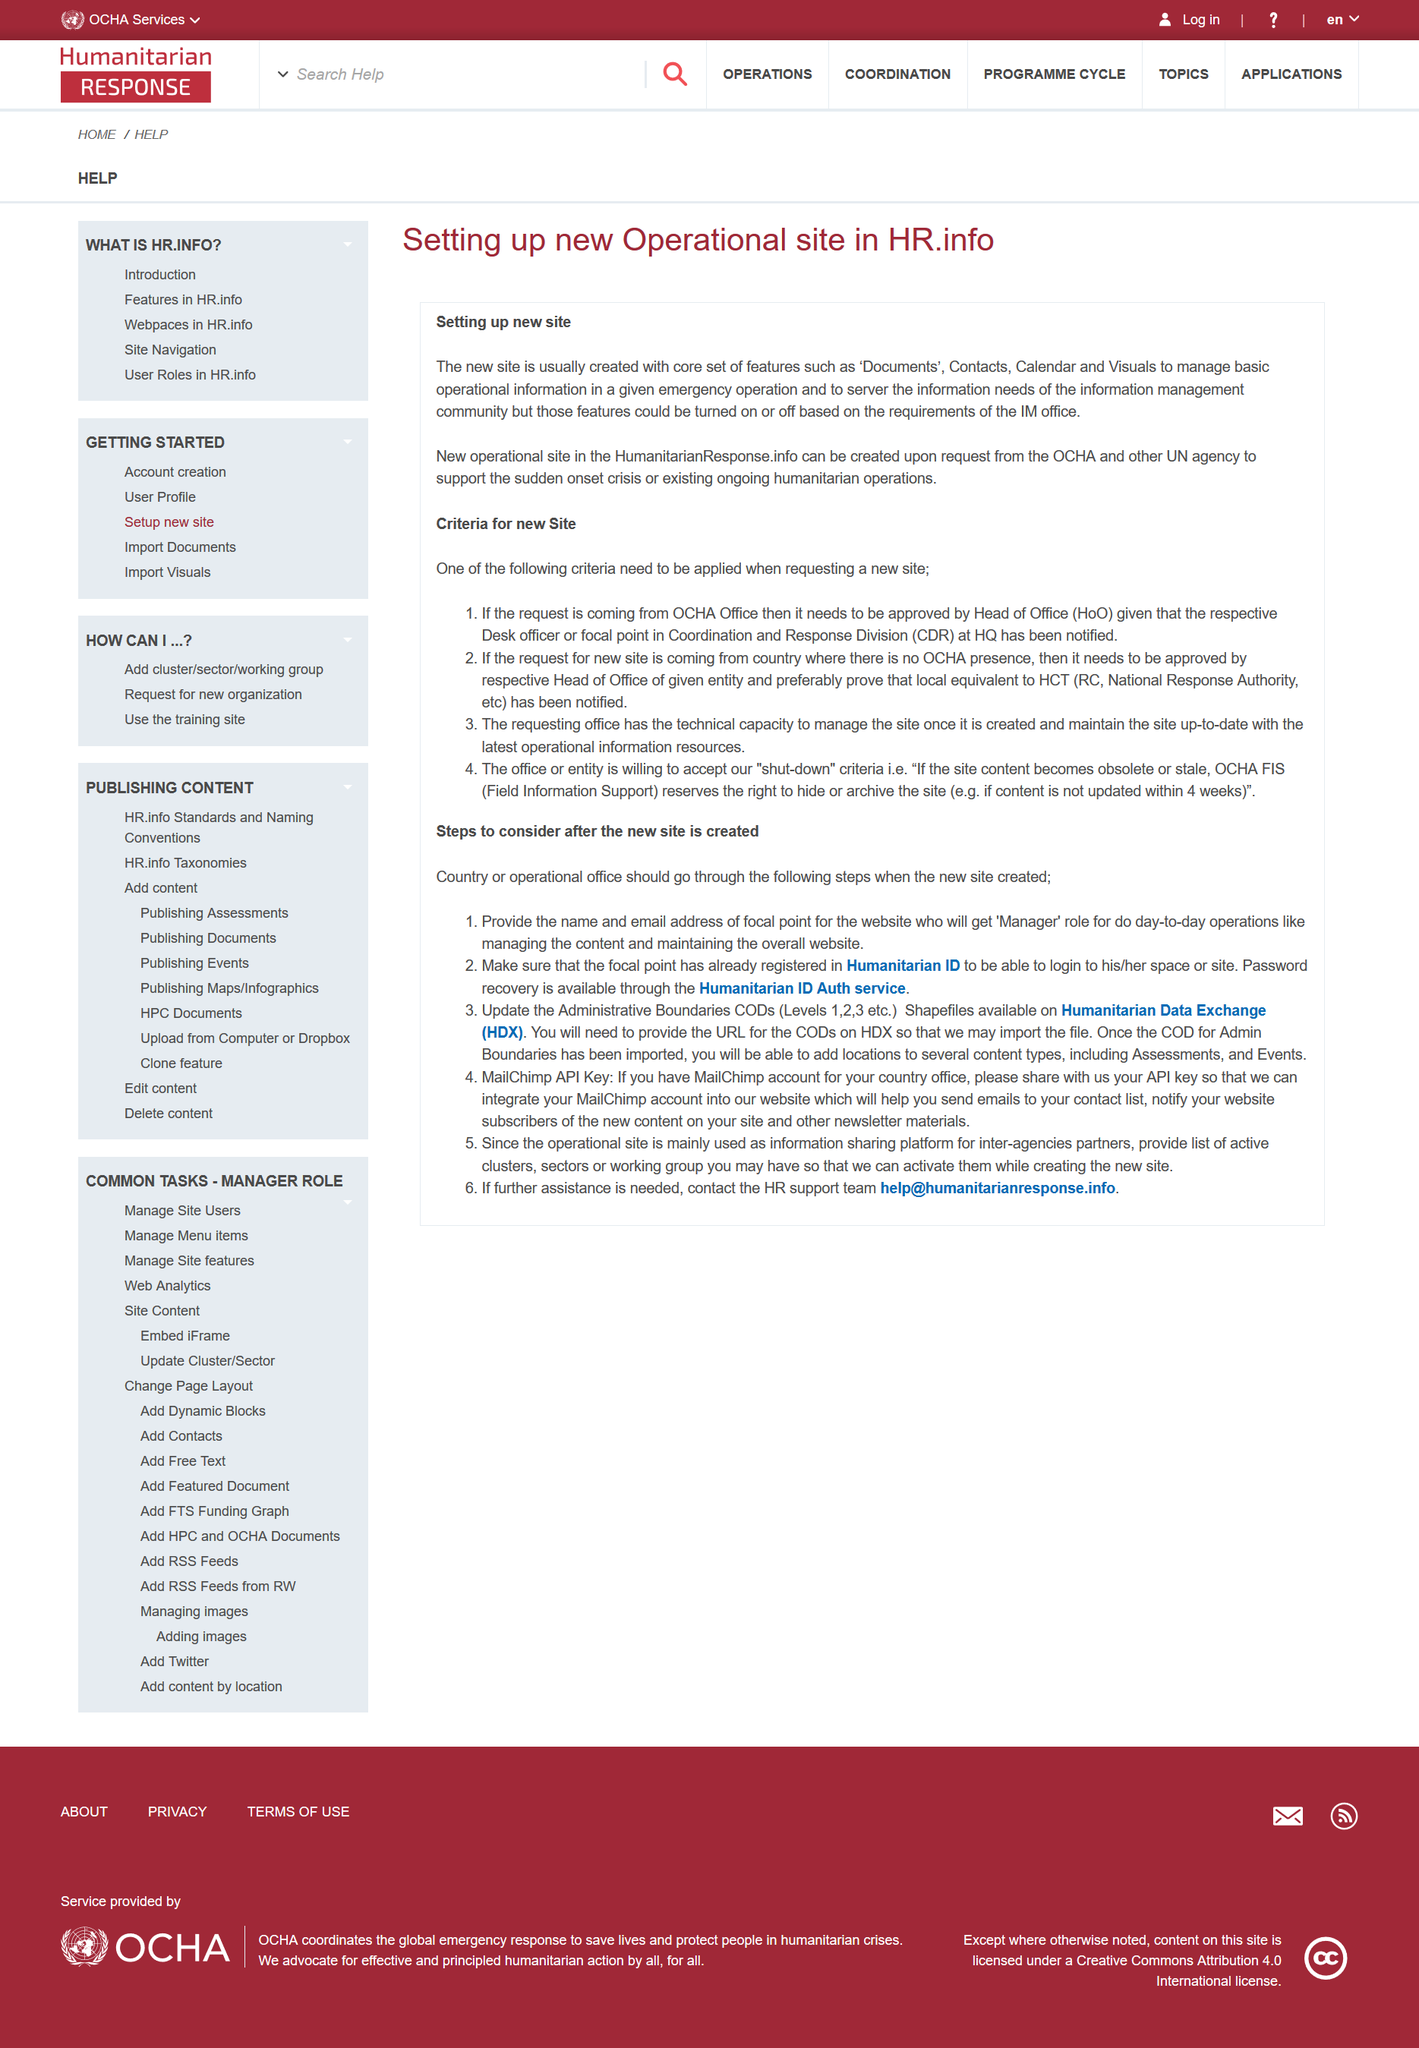List a handful of essential elements in this visual. Yes, Documents is a core feature. OCHA can create a new operational site in the HumanitarianResponse.info platform upon request. The establishment of a new operational site in HR.info has been completed, featuring a core set of features and functionality. 